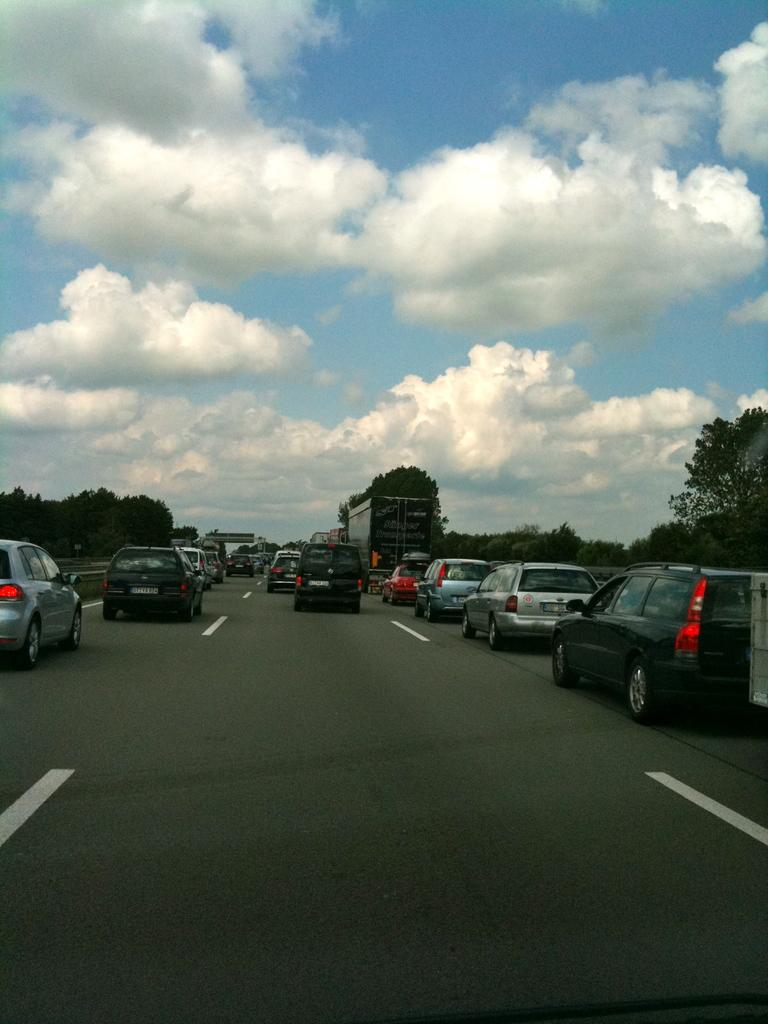What can be seen on the road in the image? There are vehicles on the road in the image. What is visible in the background of the image? There are trees and clouds visible in the background of the image. How many geese are flying over the vehicles in the image? There are no geese present in the image; it only shows vehicles on the road and trees and clouds in the background. What type of pollution can be seen coming from the vehicles in the image? The image does not provide any information about pollution or emissions from the vehicles. Can you describe the tray that is being used to serve food in the image? There is no tray present in the image. 